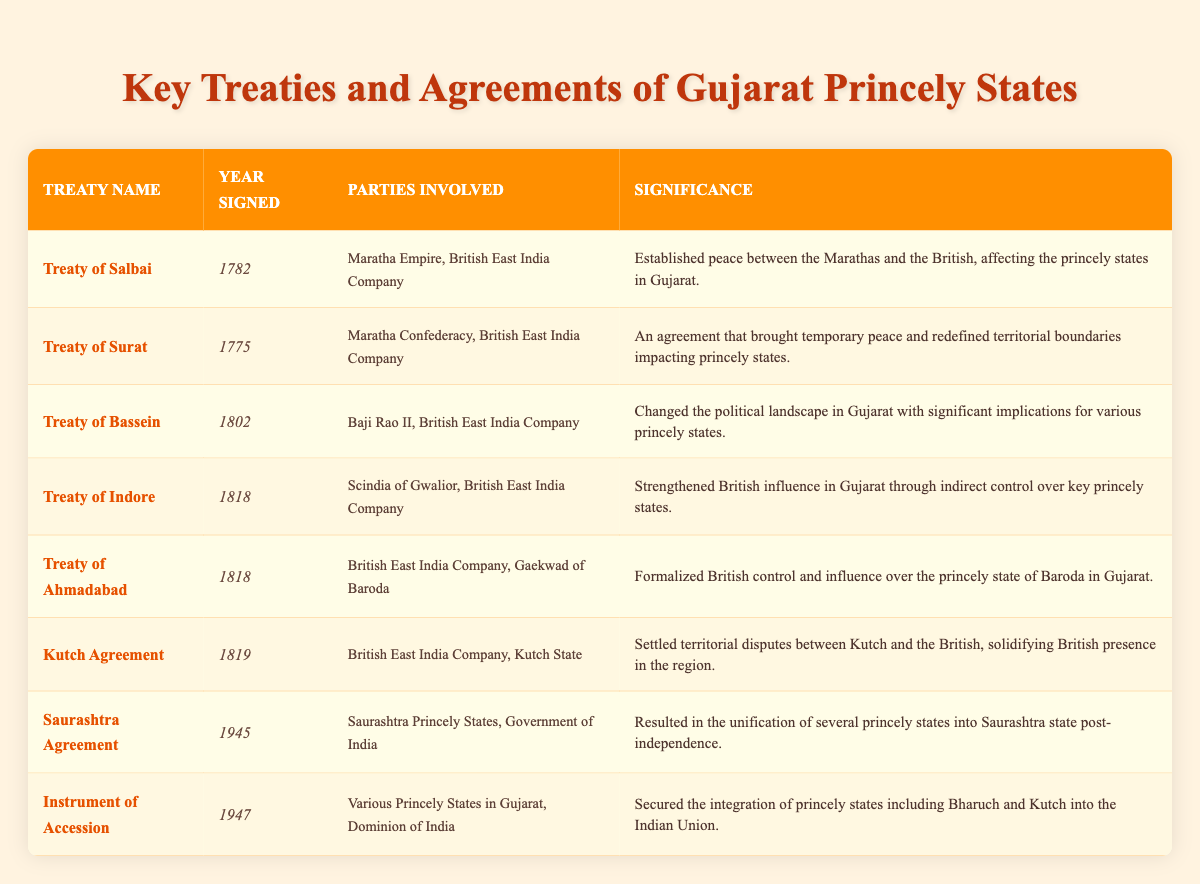What year was the Treaty of Surat signed? The table lists the Treaty of Surat in the row corresponding to that treaty, where the year signed is explicitly stated as 1775.
Answer: 1775 Which parties were involved in the Treaty of Ahmadabad? By examining the row for the Treaty of Ahmadabad, you can see that the parties involved are the British East India Company and the Gaekwad of Baroda.
Answer: British East India Company, Gaekwad of Baroda How many treaties were signed in the year 1818? The table includes two treaties signed in 1818: the Treaty of Indore and the Treaty of Ahmadabad. Therefore, the total number of treaties for that year is 2.
Answer: 2 Was the Instrument of Accession signed before or after 1945? Looking at the years mentioned in the table, the Instrument of Accession is signed in 1947, which is after 1945.
Answer: After What is the significance of the Treaty of Bassein? The significance column for the Treaty of Bassein states that it changed the political landscape in Gujarat with significant implications for various princely states.
Answer: It changed the political landscape in Gujarat Which treaty was signed last and what was its year? By reviewing the years in the table, the last treaty is the Instrument of Accession, which was signed in 1947.
Answer: Instrument of Accession, 1947 Did the Saurashtra Agreement unify multiple princely states? Referring to the significance of the Saurashtra Agreement, it states that it resulted in the unification of several princely states into Saurashtra state. Therefore, the answer is yes.
Answer: Yes What treaty formalized British control over Baroda? According to the table, the Treaty of Ahmadabad formalized British control and influence over the princely state of Baroda in Gujarat.
Answer: Treaty of Ahmadabad 